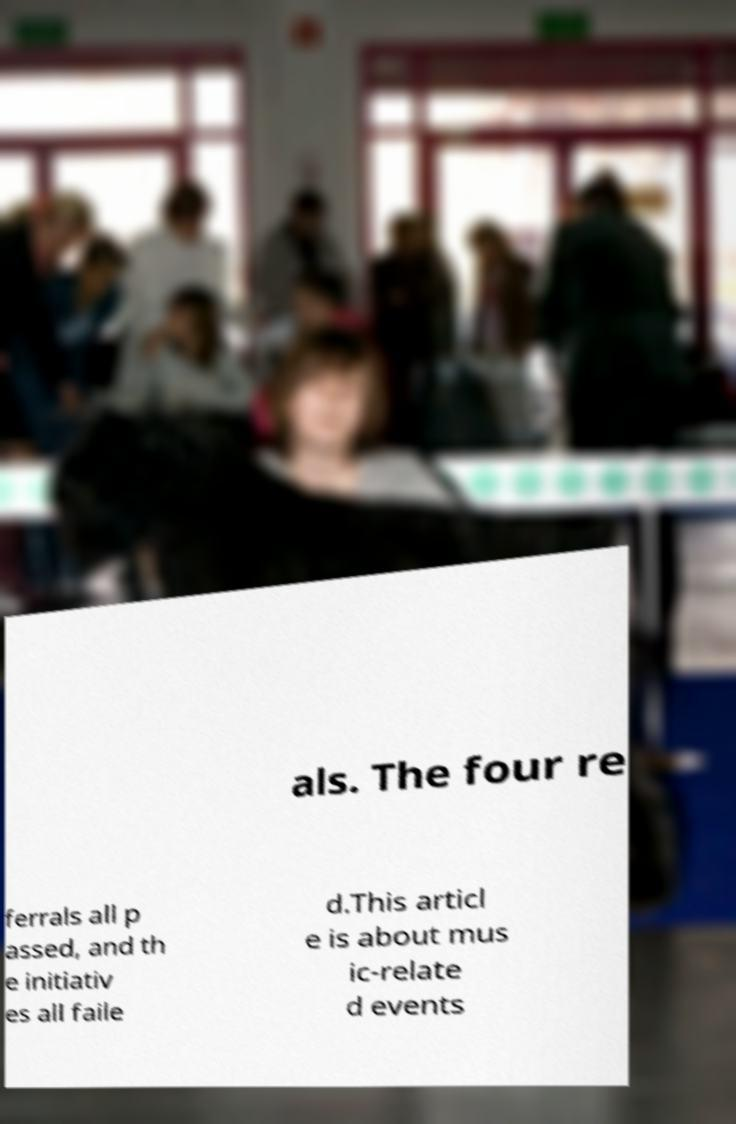Can you accurately transcribe the text from the provided image for me? als. The four re ferrals all p assed, and th e initiativ es all faile d.This articl e is about mus ic-relate d events 